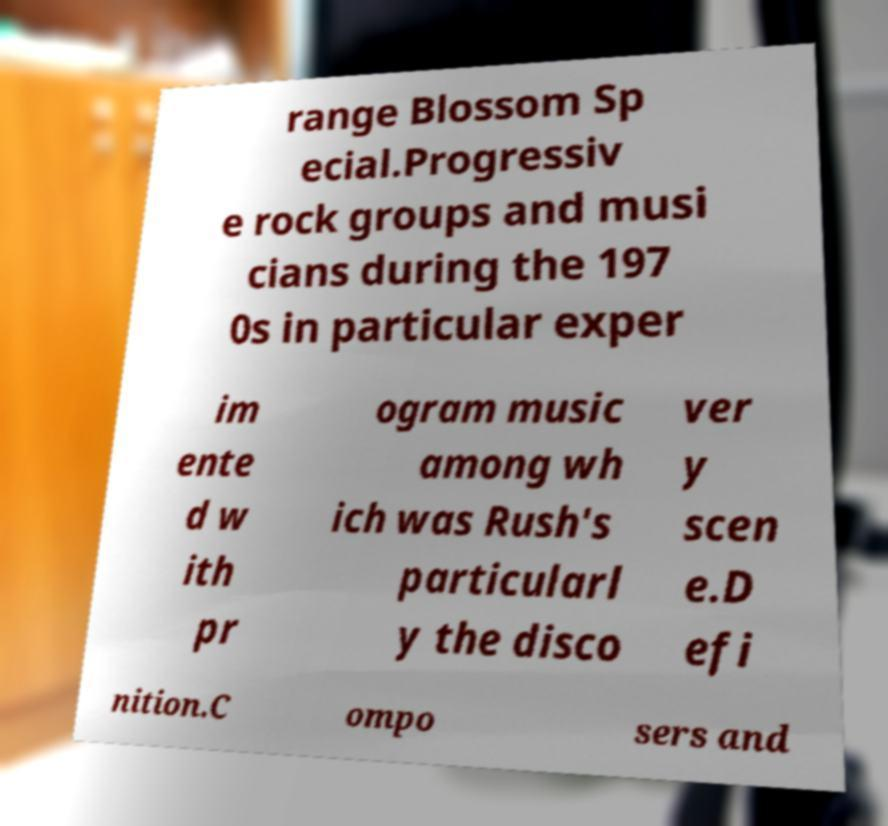Could you assist in decoding the text presented in this image and type it out clearly? range Blossom Sp ecial.Progressiv e rock groups and musi cians during the 197 0s in particular exper im ente d w ith pr ogram music among wh ich was Rush's particularl y the disco ver y scen e.D efi nition.C ompo sers and 